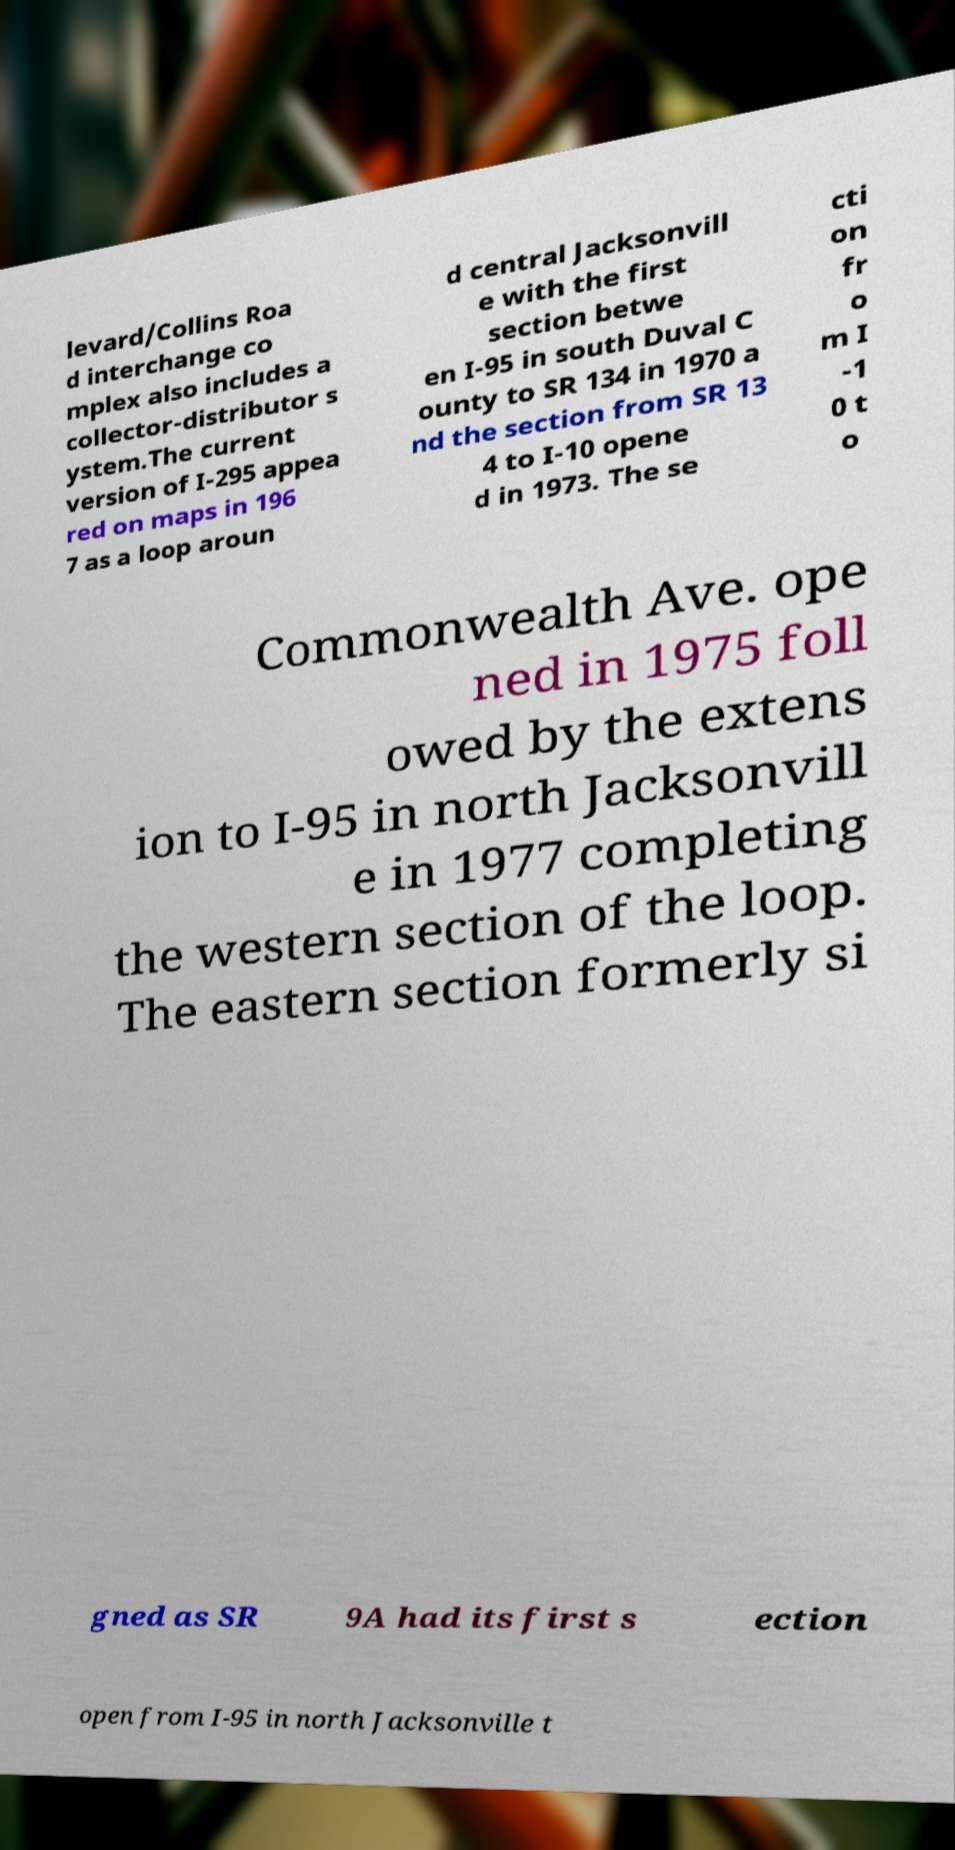For documentation purposes, I need the text within this image transcribed. Could you provide that? levard/Collins Roa d interchange co mplex also includes a collector-distributor s ystem.The current version of I-295 appea red on maps in 196 7 as a loop aroun d central Jacksonvill e with the first section betwe en I-95 in south Duval C ounty to SR 134 in 1970 a nd the section from SR 13 4 to I-10 opene d in 1973. The se cti on fr o m I -1 0 t o Commonwealth Ave. ope ned in 1975 foll owed by the extens ion to I-95 in north Jacksonvill e in 1977 completing the western section of the loop. The eastern section formerly si gned as SR 9A had its first s ection open from I-95 in north Jacksonville t 